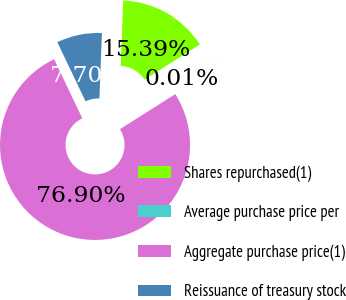Convert chart. <chart><loc_0><loc_0><loc_500><loc_500><pie_chart><fcel>Shares repurchased(1)<fcel>Average purchase price per<fcel>Aggregate purchase price(1)<fcel>Reissuance of treasury stock<nl><fcel>15.39%<fcel>0.01%<fcel>76.9%<fcel>7.7%<nl></chart> 